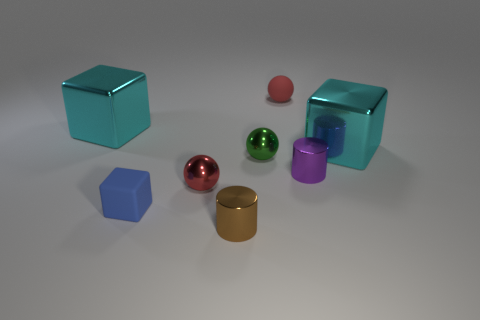Which objects in the scene have the most vibrant colors? The objects in the image with the most vibrant colors are the green and the red spheres. Their colors are vivid and stand out against the more muted tones of the other objects and the background. 